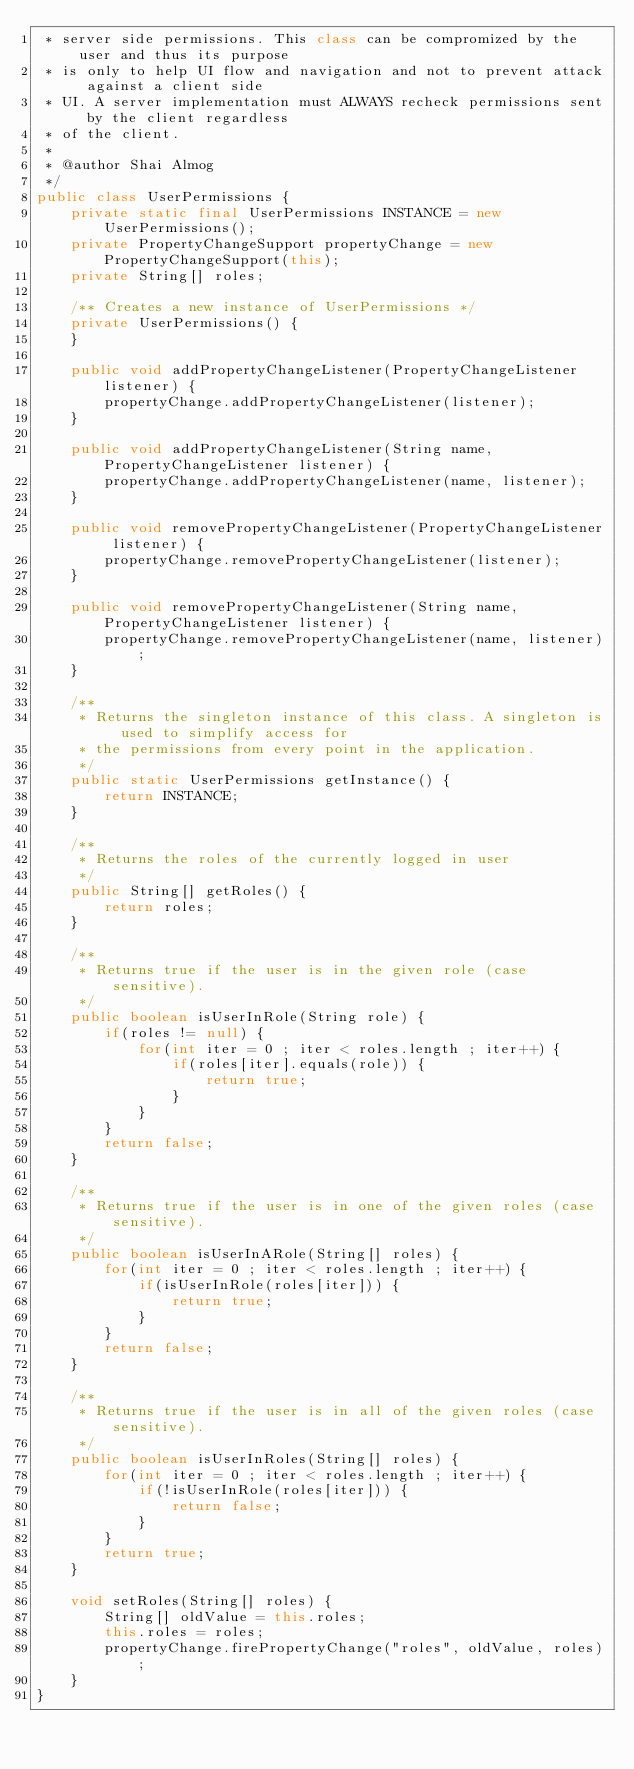<code> <loc_0><loc_0><loc_500><loc_500><_Java_> * server side permissions. This class can be compromized by the user and thus its purpose
 * is only to help UI flow and navigation and not to prevent attack against a client side
 * UI. A server implementation must ALWAYS recheck permissions sent by the client regardless
 * of the client.
 *
 * @author Shai Almog
 */
public class UserPermissions {
    private static final UserPermissions INSTANCE = new UserPermissions();
    private PropertyChangeSupport propertyChange = new PropertyChangeSupport(this);
    private String[] roles;
    
    /** Creates a new instance of UserPermissions */
    private UserPermissions() {
    }
    
    public void addPropertyChangeListener(PropertyChangeListener listener) {
        propertyChange.addPropertyChangeListener(listener);
    }

    public void addPropertyChangeListener(String name, PropertyChangeListener listener) {
        propertyChange.addPropertyChangeListener(name, listener);
    }
    
    public void removePropertyChangeListener(PropertyChangeListener listener) {
        propertyChange.removePropertyChangeListener(listener);
    }

    public void removePropertyChangeListener(String name, PropertyChangeListener listener) {
        propertyChange.removePropertyChangeListener(name, listener);
    }

    /**
     * Returns the singleton instance of this class. A singleton is used to simplify access for
     * the permissions from every point in the application.
     */
    public static UserPermissions getInstance() {
        return INSTANCE;
    }
    
    /**
     * Returns the roles of the currently logged in user
     */
    public String[] getRoles() {
        return roles;
    }
    
    /**
     * Returns true if the user is in the given role (case sensitive).
     */
    public boolean isUserInRole(String role) {
        if(roles != null) {
            for(int iter = 0 ; iter < roles.length ; iter++) {
                if(roles[iter].equals(role)) {
                    return true;
                }
            }
        } 
        return false;
    }

    /**
     * Returns true if the user is in one of the given roles (case sensitive).
     */
    public boolean isUserInARole(String[] roles) {
        for(int iter = 0 ; iter < roles.length ; iter++) {
            if(isUserInRole(roles[iter])) {
                return true;
            }
        }
        return false;
    }

    /**
     * Returns true if the user is in all of the given roles (case sensitive).
     */
    public boolean isUserInRoles(String[] roles) {
        for(int iter = 0 ; iter < roles.length ; iter++) {
            if(!isUserInRole(roles[iter])) {
                return false;
            }
        }
        return true;
    }
    
    void setRoles(String[] roles) {
        String[] oldValue = this.roles;
        this.roles = roles;
        propertyChange.firePropertyChange("roles", oldValue, roles);
    }
}

</code> 